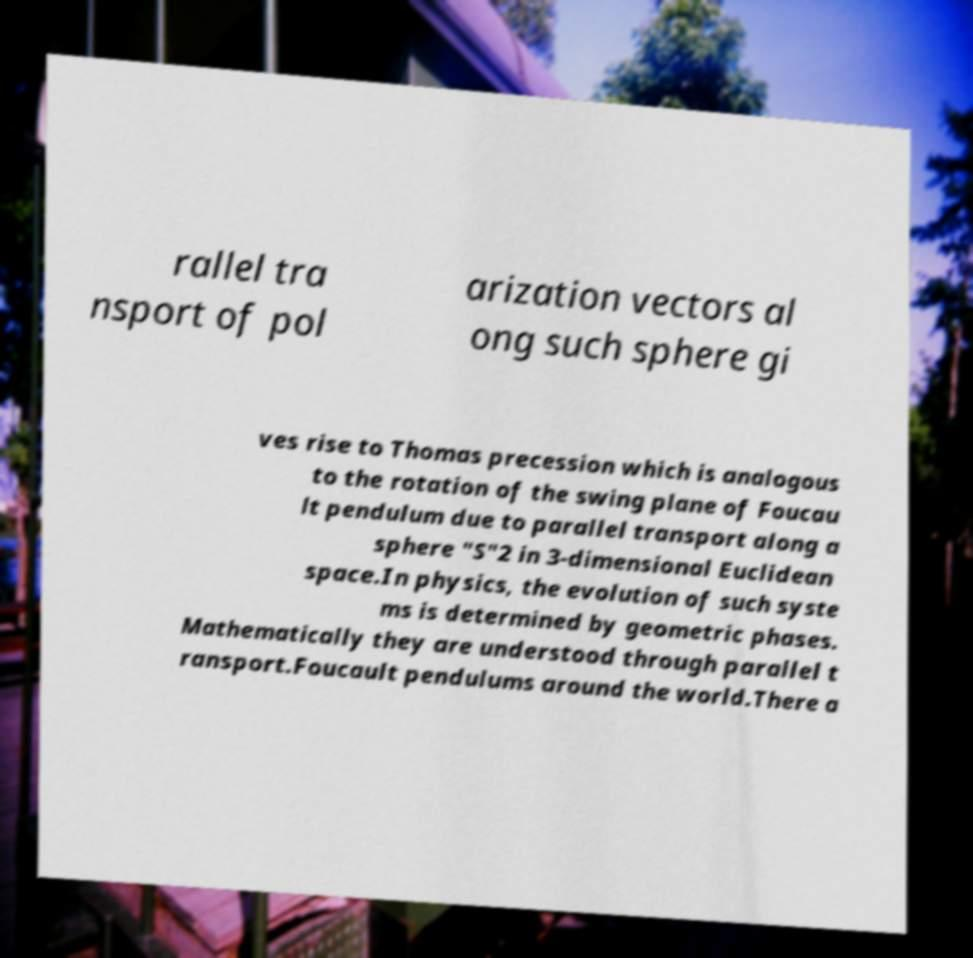Could you extract and type out the text from this image? rallel tra nsport of pol arization vectors al ong such sphere gi ves rise to Thomas precession which is analogous to the rotation of the swing plane of Foucau lt pendulum due to parallel transport along a sphere "S"2 in 3-dimensional Euclidean space.In physics, the evolution of such syste ms is determined by geometric phases. Mathematically they are understood through parallel t ransport.Foucault pendulums around the world.There a 